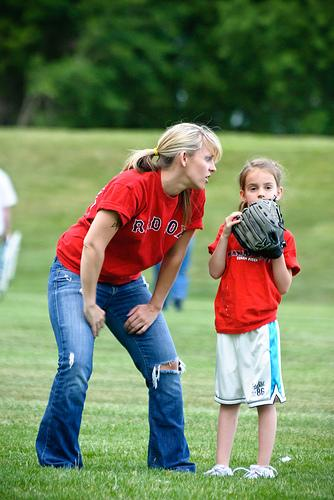What is unusual about the fingernails of the hand in the image, and what do they match with? The hand has blue fingernail polish on the nails, which matches the blue stripe on the shorts. Explain the interaction between the girl with the glove and the woman with the tattoo. The woman is giving advice to the girl with the baseball glove, while the girl listens attentively with a dreamy look on her face. Comment on the presence and location of a tattoo, and any other body art found in the image. There is a tattoo on the woman's arm, and blue fingernail polish on the nails. Describe the look on the girl with dreamy look's face and what she is doing. The girl with the dreamy look is staring ahead, wearing a baseball glove, ready to receive advice from the woman. How do the branches of the tree in the image appear, and what is their environment? The branches are drooping and curved, and they are in the shade. Describe the hair color and hairstyle of the woman with a ponytail. The woman has blonde hair pulled back in a ponytail with bangs and a yellow hairband. Mention the objects on the ground and describe their appearance. There is bright green healthy grass and grass covered field with a slope in the back. What type of accessory is the girl with dark brown eyes wearing and what is its use? The girl with dark brown eyes is wearing a black baseball glove, which is used for catching a baseball. Enumerate the pieces of clothing the woman is wearing and their colors. The woman is wearing torn blue jeans, a red cotton shirt, and white girls gym shoes. 